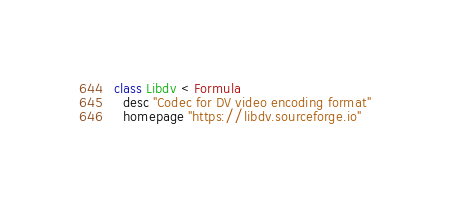<code> <loc_0><loc_0><loc_500><loc_500><_Ruby_>class Libdv < Formula
  desc "Codec for DV video encoding format"
  homepage "https://libdv.sourceforge.io"</code> 